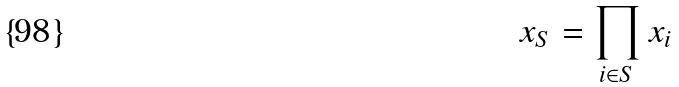<formula> <loc_0><loc_0><loc_500><loc_500>x _ { S } = \prod _ { i \in S } x _ { i }</formula> 